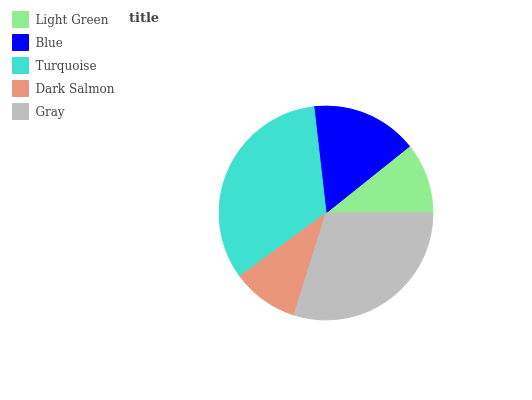Is Dark Salmon the minimum?
Answer yes or no. Yes. Is Turquoise the maximum?
Answer yes or no. Yes. Is Blue the minimum?
Answer yes or no. No. Is Blue the maximum?
Answer yes or no. No. Is Blue greater than Light Green?
Answer yes or no. Yes. Is Light Green less than Blue?
Answer yes or no. Yes. Is Light Green greater than Blue?
Answer yes or no. No. Is Blue less than Light Green?
Answer yes or no. No. Is Blue the high median?
Answer yes or no. Yes. Is Blue the low median?
Answer yes or no. Yes. Is Gray the high median?
Answer yes or no. No. Is Gray the low median?
Answer yes or no. No. 